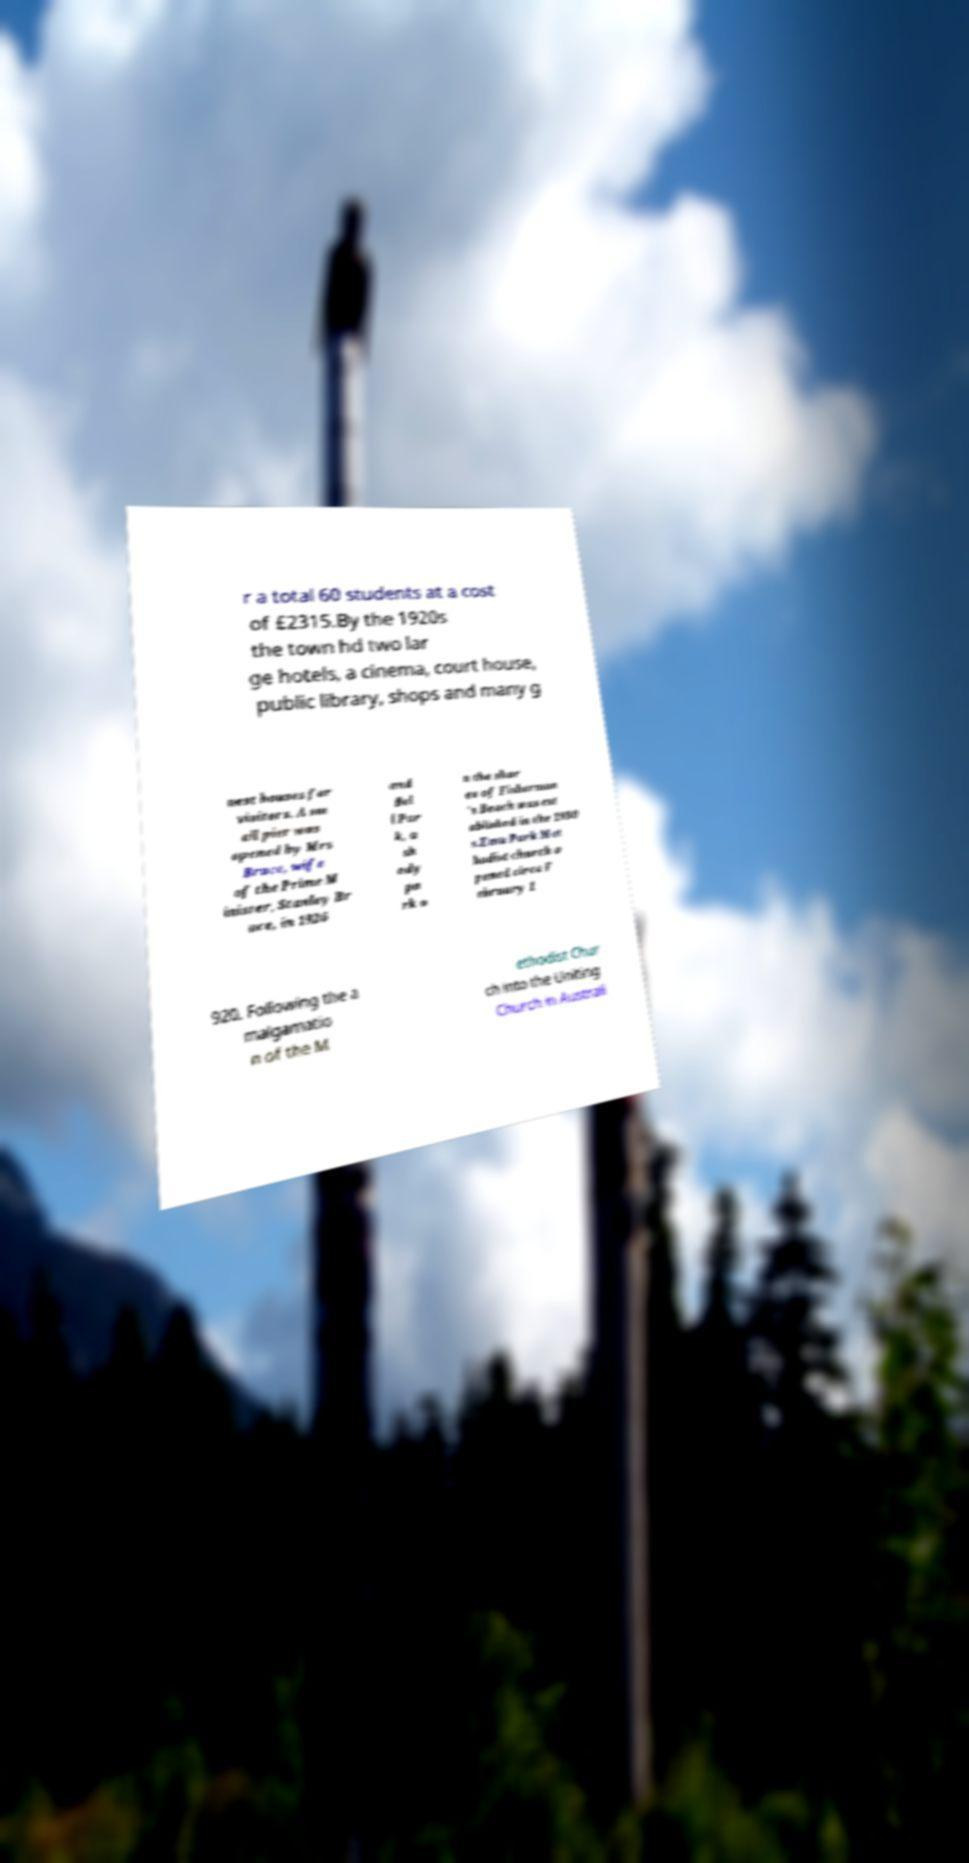What messages or text are displayed in this image? I need them in a readable, typed format. r a total 60 students at a cost of £2315.By the 1920s the town hd two lar ge hotels, a cinema, court house, public library, shops and many g uest houses for visitors. A sm all pier was opened by Mrs Bruce, wife of the Prime M inister, Stanley Br uce, in 1926 and Bel l Par k, a sh ady pa rk o n the shor es of Fisherman 's Beach was est ablished in the 1930 s.Emu Park Met hodist church o pened circa F ebruary 1 920. Following the a malgamatio n of the M ethodist Chur ch into the Uniting Church in Australi 